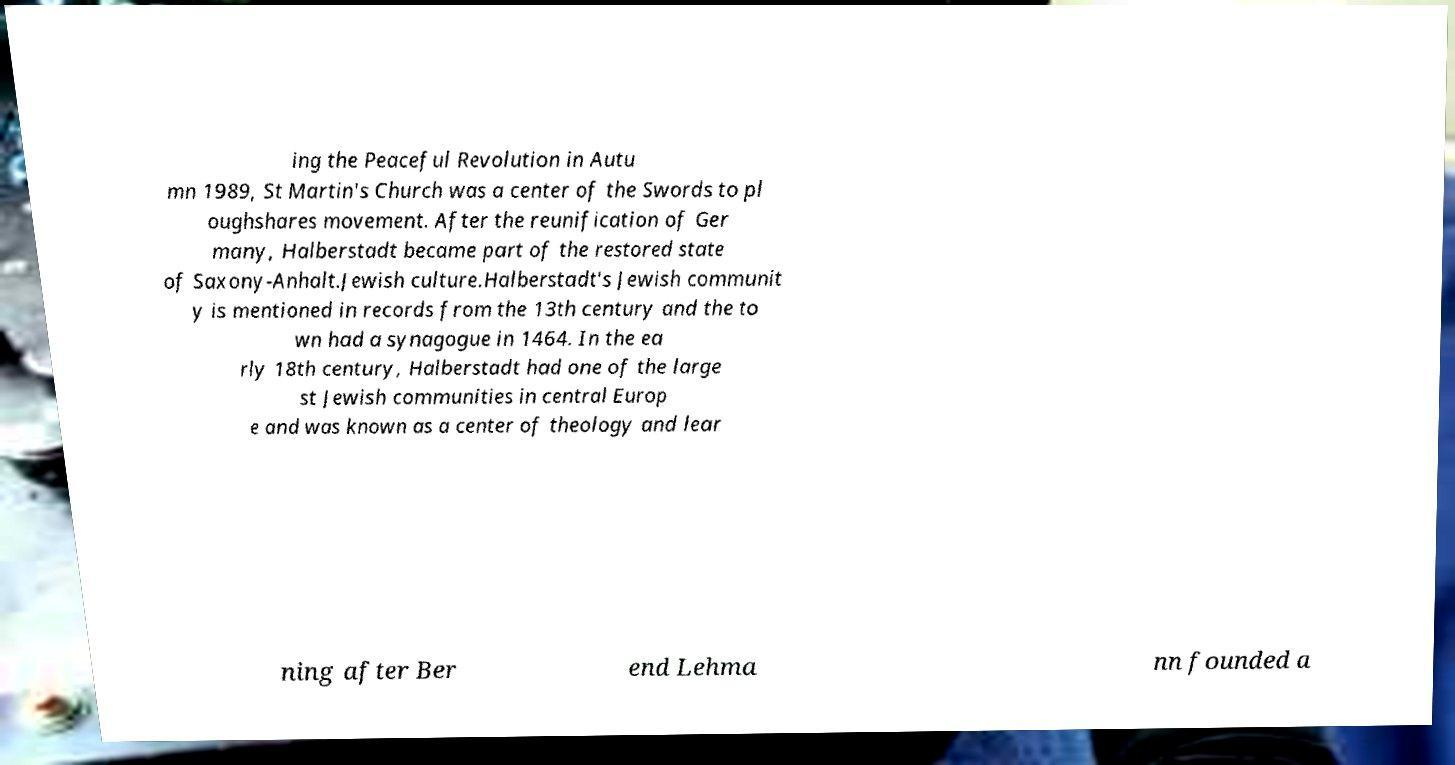For documentation purposes, I need the text within this image transcribed. Could you provide that? ing the Peaceful Revolution in Autu mn 1989, St Martin's Church was a center of the Swords to pl oughshares movement. After the reunification of Ger many, Halberstadt became part of the restored state of Saxony-Anhalt.Jewish culture.Halberstadt's Jewish communit y is mentioned in records from the 13th century and the to wn had a synagogue in 1464. In the ea rly 18th century, Halberstadt had one of the large st Jewish communities in central Europ e and was known as a center of theology and lear ning after Ber end Lehma nn founded a 